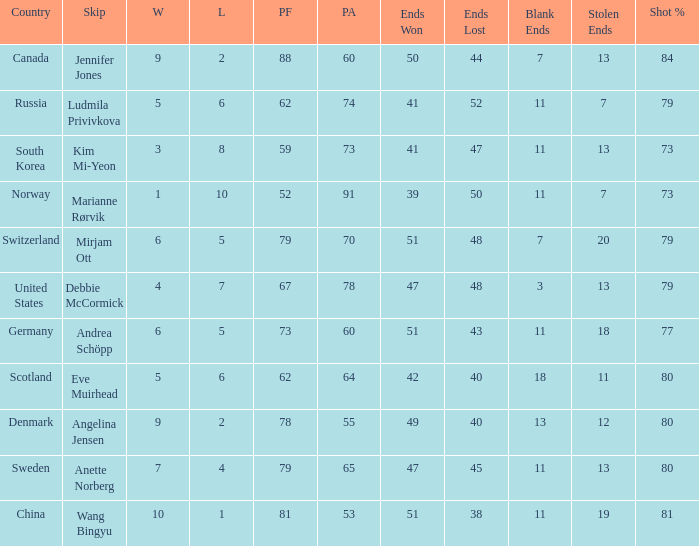When the country was Scotland, how many ends were won? 1.0. 